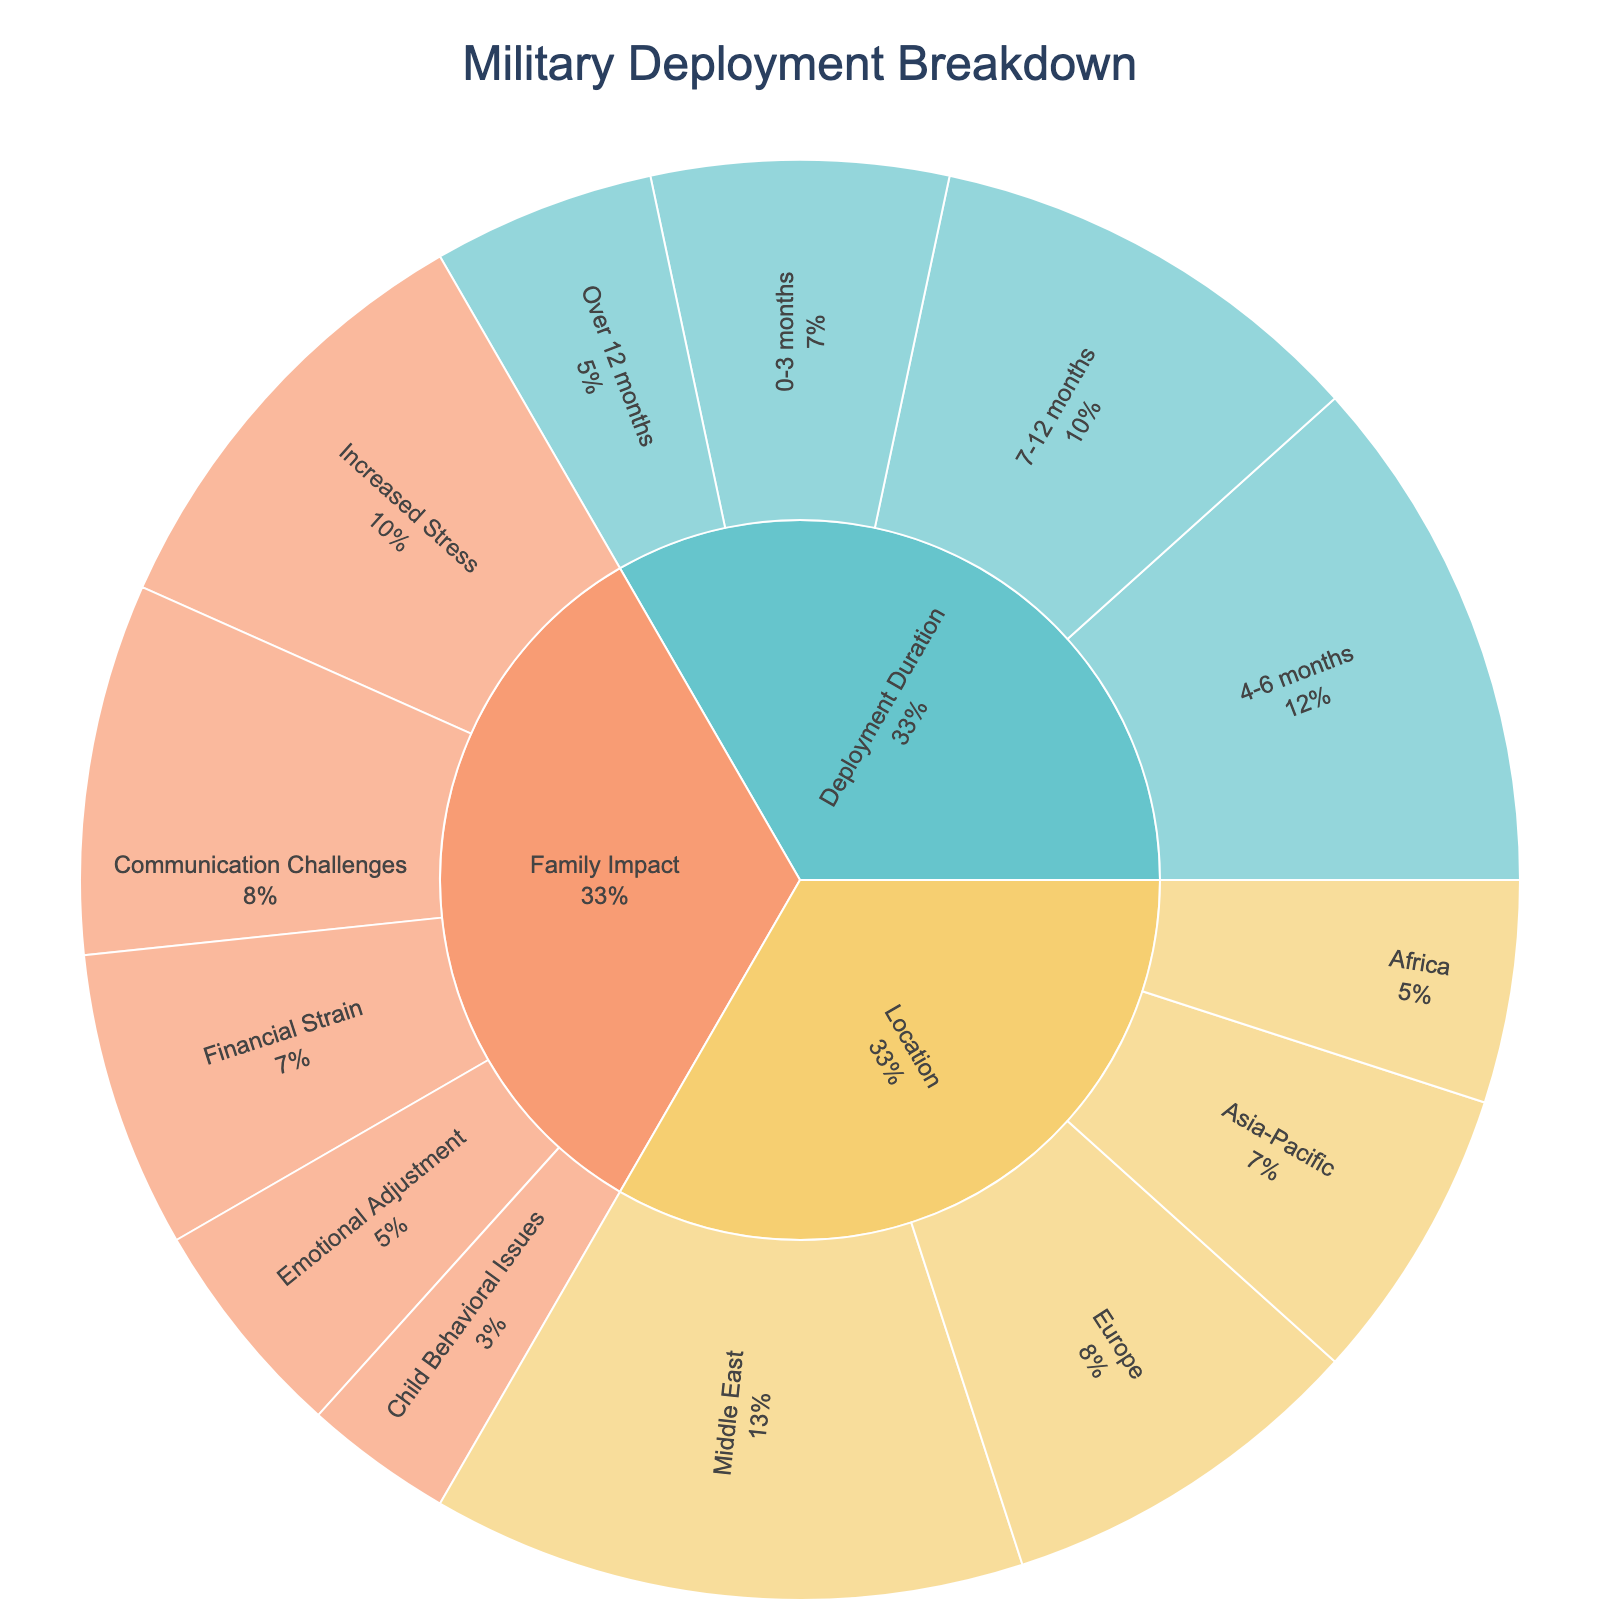What's the title of the plot? The title is typically displayed at the top of the plot. In this plot, it is centered at the top.
Answer: Military Deployment Breakdown How many main categories are represented in the plot? The main categories are usually the first level of segments from the center. Here, there are three main categories visible from the plot: Deployment Duration, Location, and Family Impact.
Answer: 3 Which subcategory under 'Deployment Duration' has the highest value? You need to look at the subcategories extending from 'Deployment Duration' and find the one with the largest segment. From the plot, '4-6 months' has the highest value.
Answer: 4-6 months Which location has the lowest number of deployments? Look at the segments under the 'Location' category and identify the smallest segment. Here, 'Africa' has the smallest segment.
Answer: Africa What percentage of deployments are of '0-3 months' duration? The percentage can be seen in the plot near the '0-3 months' segment. By examining the visual data, '0-3 months' duration constitutes a percentage marked in the plot.
Answer: 20% What is the sum of the values for all deployment durations over 6 months? Sum the values for '7-12 months' and 'Over 12 months' by looking at their segments' values in the plot. 30 (7-12 months) + 15 (Over 12 months) = 45
Answer: 45 Which family impact has the greatest value? Identify the largest segment within the 'Family Impact' category. 'Increased Stress' has the greatest value among the family impacts.
Answer: Increased Stress Compare the number of deployments in Europe to Asia-Pacific. Which has more? Examine the segments under the 'Location' category and compare their sizes. Europe has 25, while Asia-Pacific has 20, so Europe has more deployments.
Answer: Europe What is the difference between the highest and lowest values in the 'Family Impact' category? Identify the highest and lowest values in the 'Family Impact' category and subtract the smallest from the largest. Highest: Increased Stress (30), Lowest: Child Behavioral Issues (10). So, 30 - 10 = 20
Answer: 20 How many total deployments are represented in the plot? To find the total deployments, sum all the values from each subcategory represented in the plot. Adding all values: 20 + 35 + 30 + 15 + 40 + 25 + 20 + 15 = 200
Answer: 200 